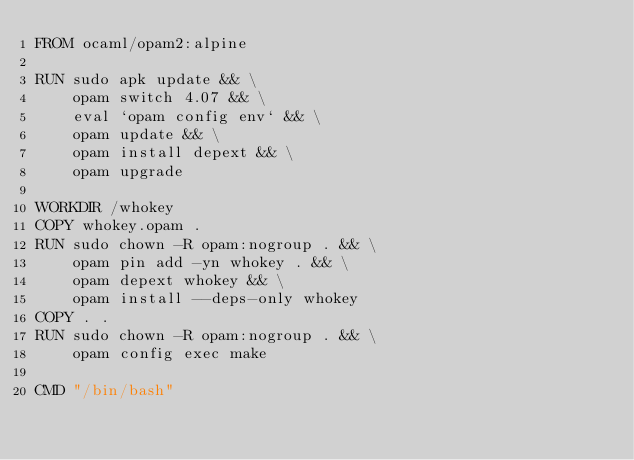<code> <loc_0><loc_0><loc_500><loc_500><_Dockerfile_>FROM ocaml/opam2:alpine

RUN sudo apk update && \
    opam switch 4.07 && \
    eval `opam config env` && \
    opam update && \
    opam install depext && \
    opam upgrade

WORKDIR /whokey
COPY whokey.opam .
RUN sudo chown -R opam:nogroup . && \
    opam pin add -yn whokey . && \
    opam depext whokey && \
    opam install --deps-only whokey
COPY . .
RUN sudo chown -R opam:nogroup . && \
    opam config exec make

CMD "/bin/bash"
</code> 